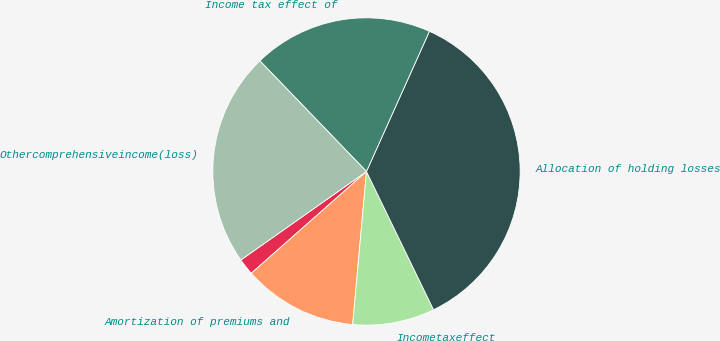Convert chart to OTSL. <chart><loc_0><loc_0><loc_500><loc_500><pie_chart><ecel><fcel>Amortization of premiums and<fcel>Incometaxeffect<fcel>Allocation of holding losses<fcel>Income tax effect of<fcel>Othercomprehensiveincome(loss)<nl><fcel>1.75%<fcel>12.05%<fcel>8.62%<fcel>36.09%<fcel>18.92%<fcel>22.56%<nl></chart> 